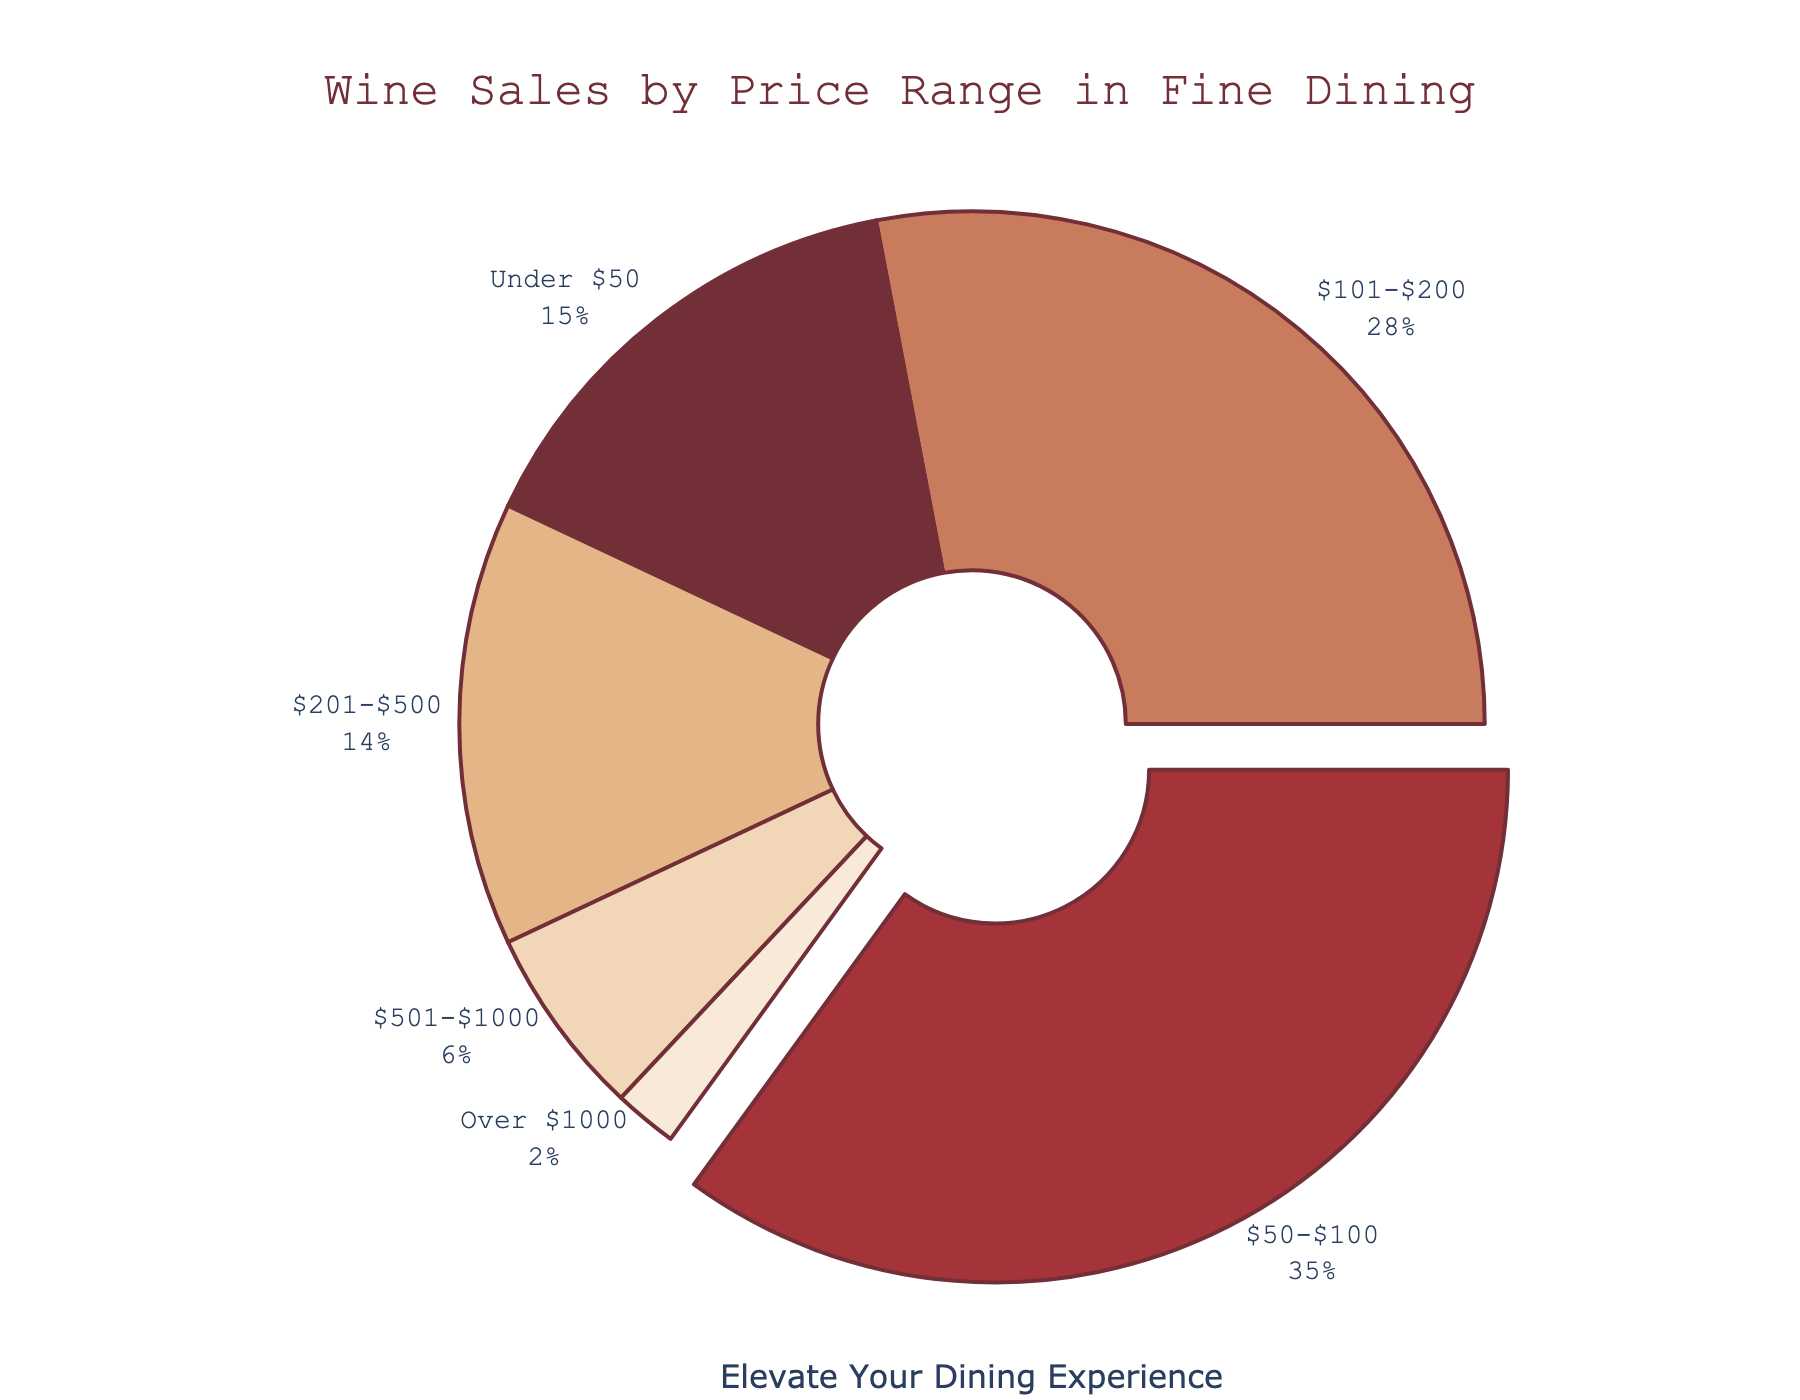What's the largest sales percentage price range for wine? The figure shows the sales percentages for different wine price ranges. By comparing these percentages, we see that the $50-$100 price range has the largest slice.
Answer: $50-$100 How much more sales percentage does the $50-$100 price range have compared to the $501-$1000 price range? The $50-$100 price range represents 35% of sales, and the $501-$1000 category represents 6%. The difference is 35% - 6% = 29%.
Answer: 29% Which price range has the smallest sales percentage? By looking at the smallest slice in the pie chart, we can see that the "Over $1000" price range represents the smallest percentage.
Answer: Over $1000 What is the combined sales percentage for the price ranges above $200? The price ranges above $200 include $201-$500 (14%), $501-$1000 (6%), and Over $1000 (2%). Adding these percentages: 14% + 6% + 2% = 22%.
Answer: 22% Is the percentage of wine sales under $50 greater than, less than, or equal to the percentage of wine sales for $201-$500? The figure shows that wines under $50 represent 15%, and wines in the $201-$500 range represent 14%. Therefore, 15% is greater than 14%.
Answer: Greater than What percentage of wine sales falls within the $101-$200 rage? This range is directly labeled with its sales percentage in the pie chart, which is 28%.
Answer: 28% How does the sum of the sales percentages for the $101-$500 price ranges compare to the total percentage of sales for wines under $100? The $101-$200 range is 28% and the $201-$500 range is 14%. Their sum is 28% + 14% = 42%. The total percentage for wines under $100 is Under $50 (15%) + $50-$100 (35%) = 50%. Therefore, 42% is less than 50%.
Answer: Less than What is the median percentage value of the different wine price ranges? To find the median, we first list the percentages in ascending order: 2%, 6%, 14%, 15%, 28%, 35%. Since there are 6 values, the median is the average of the 3rd and 4th values: (14% + 15%) / 2 = 14.5%.
Answer: 14.5% Which price range in the pie chart is represented by the darkest color? The darkest color in the pie chart corresponds to the largest section, which is the $50-$100 price range.
Answer: $50-$100 How much percentage do the top two price ranges contribute together? The top two ranges in terms of percentage are $50-$100 (35%) and $101-$200 (28%). Their combined contribution is 35% + 28% = 63%.
Answer: 63% 